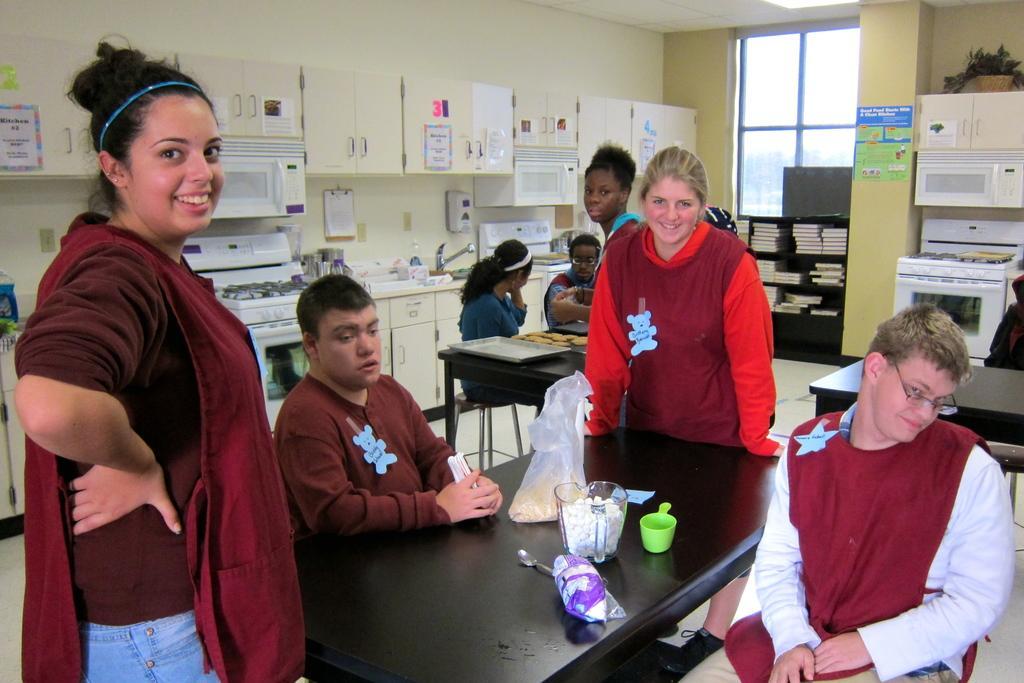Could you give a brief overview of what you see in this image? In this image I can see the group of people are in-front of the table. On the table there are some of the objects. In the back there is a countertop and the books inside the cupboard. 